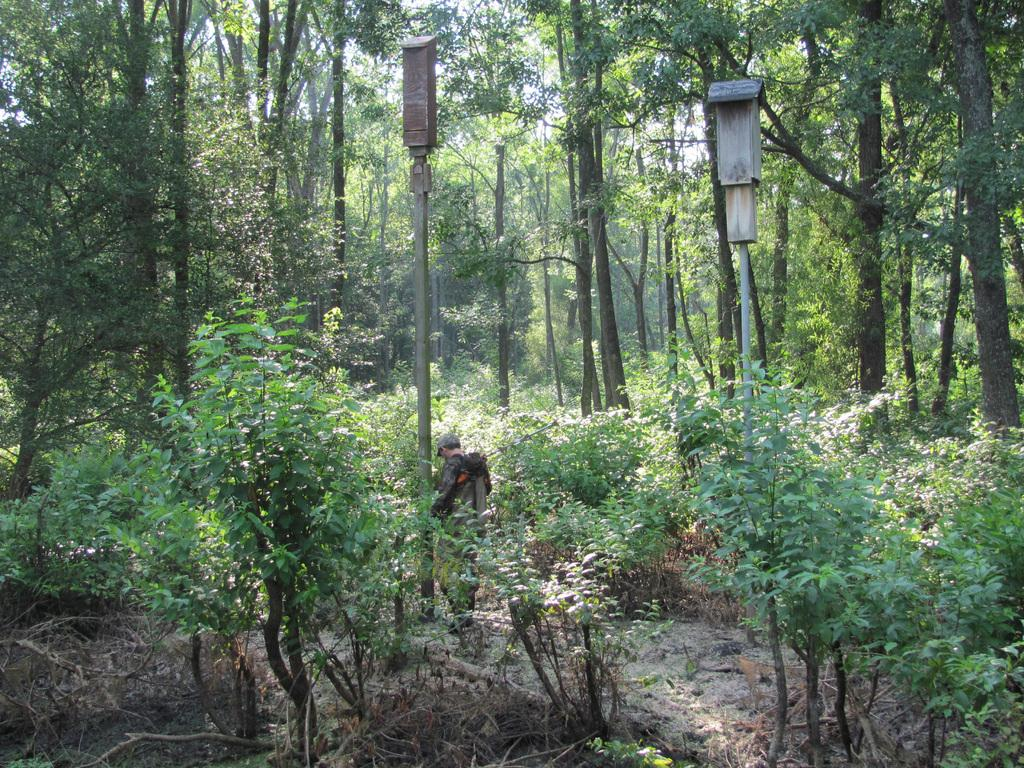What type of natural environment is depicted in the image? There is a forest in the image. What are the main features of the forest? The forest contains many trees and plants. Can you identify any man-made objects in the image? Yes, there are two poles in the image. Is there anyone present in the image? Yes, there is a person standing near one of the poles. How many rivers can be seen flowing through the forest in the image? There are no rivers visible in the image; it depicts a forest with trees and plants. 